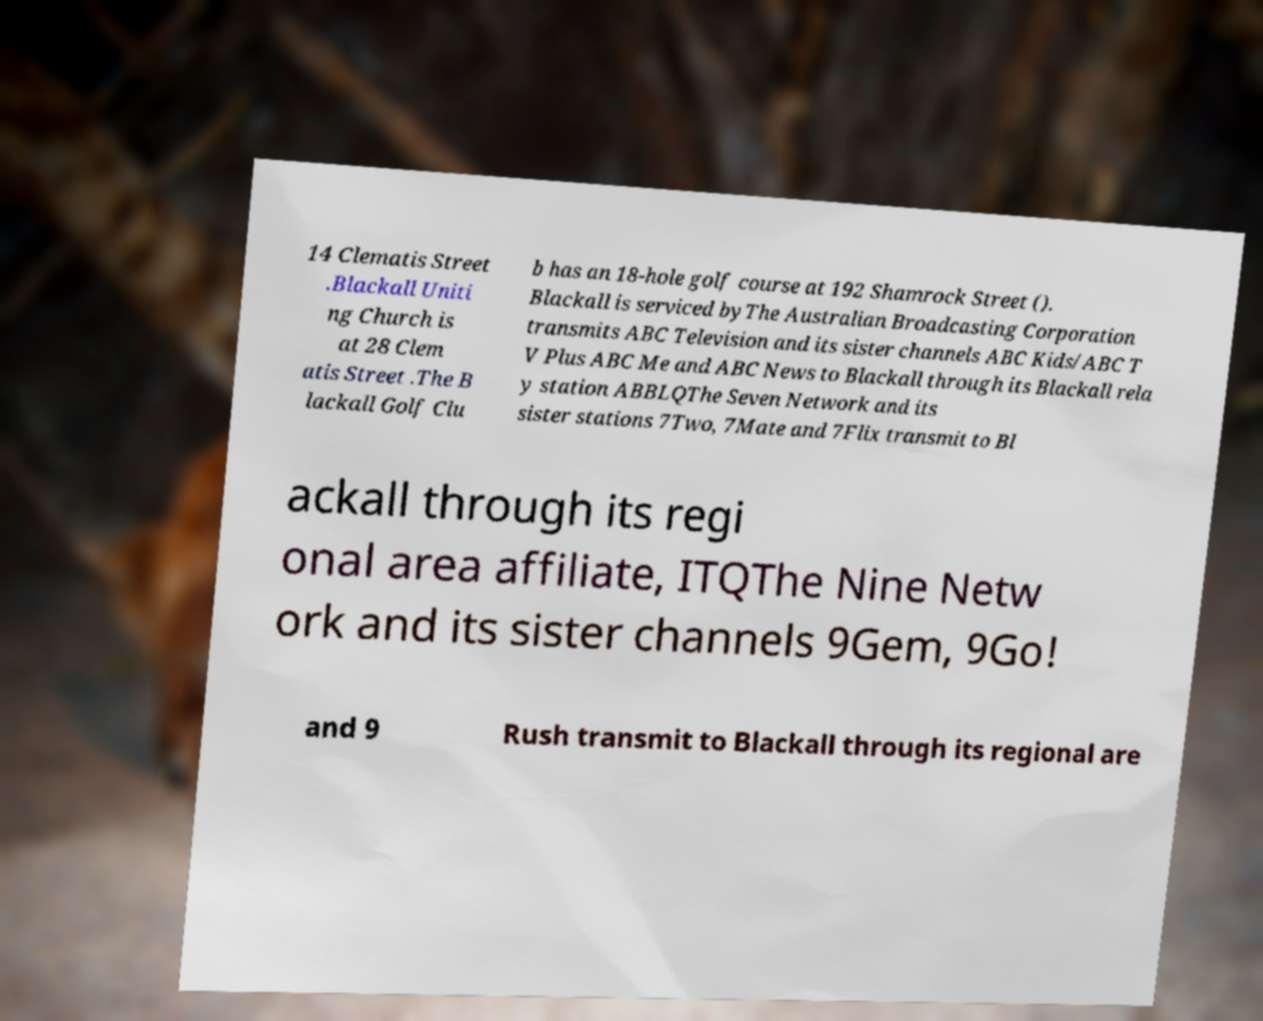Can you accurately transcribe the text from the provided image for me? 14 Clematis Street .Blackall Uniti ng Church is at 28 Clem atis Street .The B lackall Golf Clu b has an 18-hole golf course at 192 Shamrock Street (). Blackall is serviced byThe Australian Broadcasting Corporation transmits ABC Television and its sister channels ABC Kids/ABC T V Plus ABC Me and ABC News to Blackall through its Blackall rela y station ABBLQThe Seven Network and its sister stations 7Two, 7Mate and 7Flix transmit to Bl ackall through its regi onal area affiliate, ITQThe Nine Netw ork and its sister channels 9Gem, 9Go! and 9 Rush transmit to Blackall through its regional are 